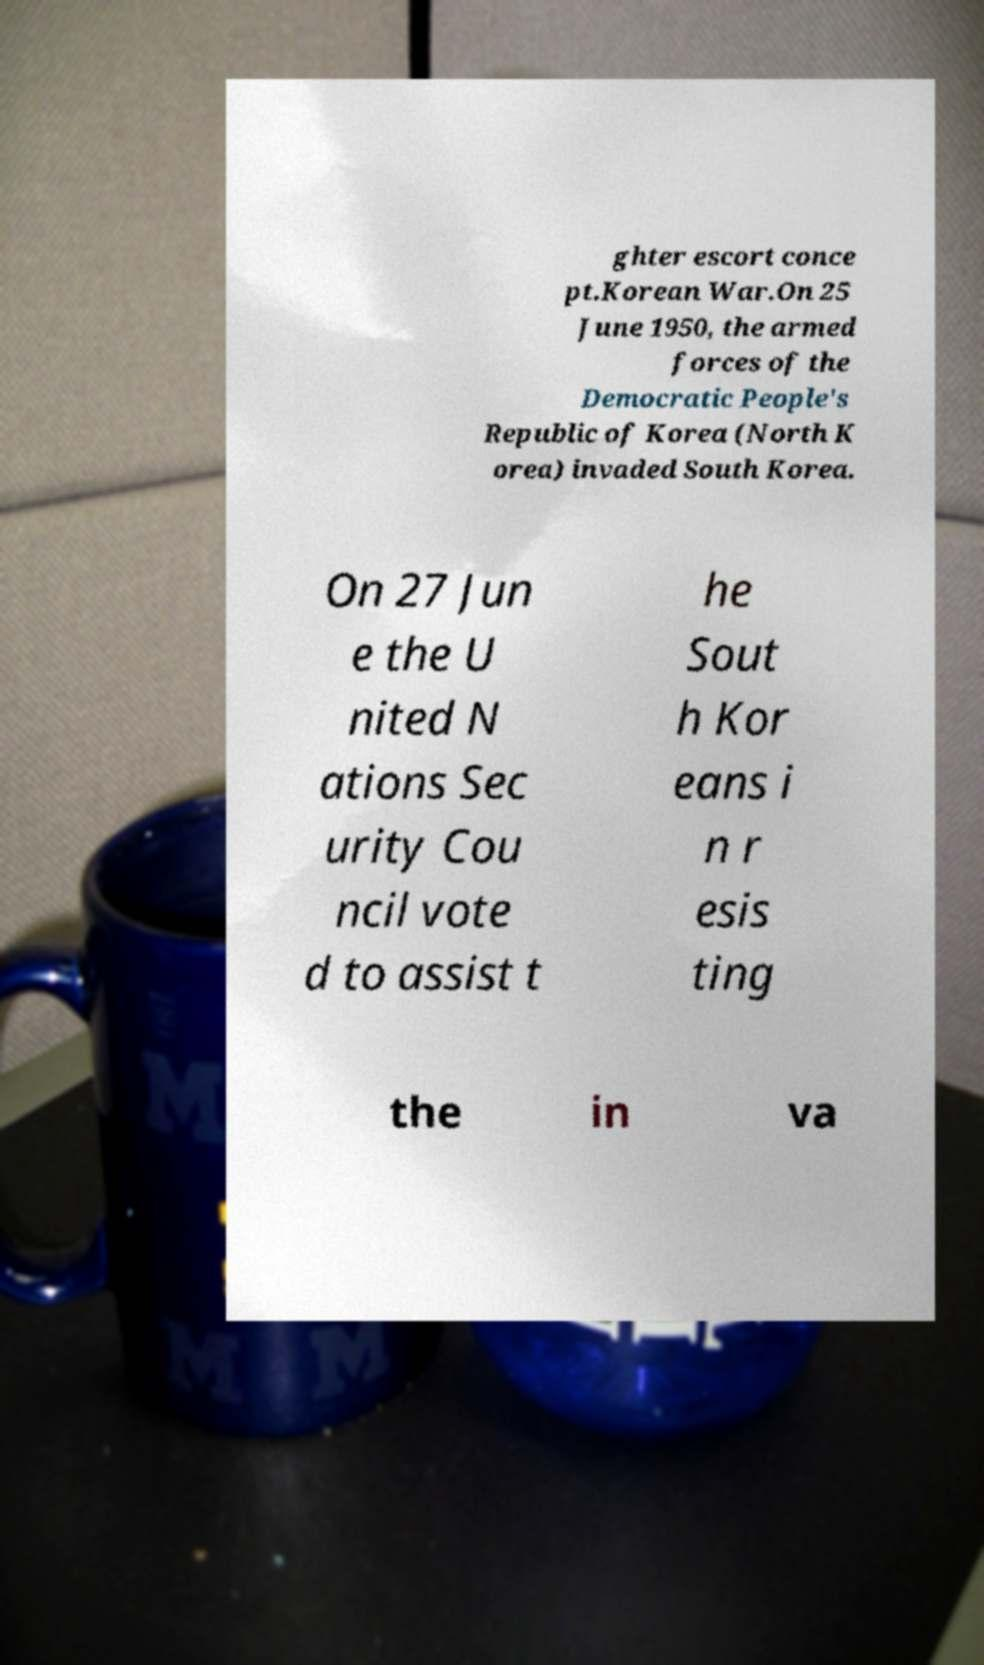What messages or text are displayed in this image? I need them in a readable, typed format. ghter escort conce pt.Korean War.On 25 June 1950, the armed forces of the Democratic People's Republic of Korea (North K orea) invaded South Korea. On 27 Jun e the U nited N ations Sec urity Cou ncil vote d to assist t he Sout h Kor eans i n r esis ting the in va 